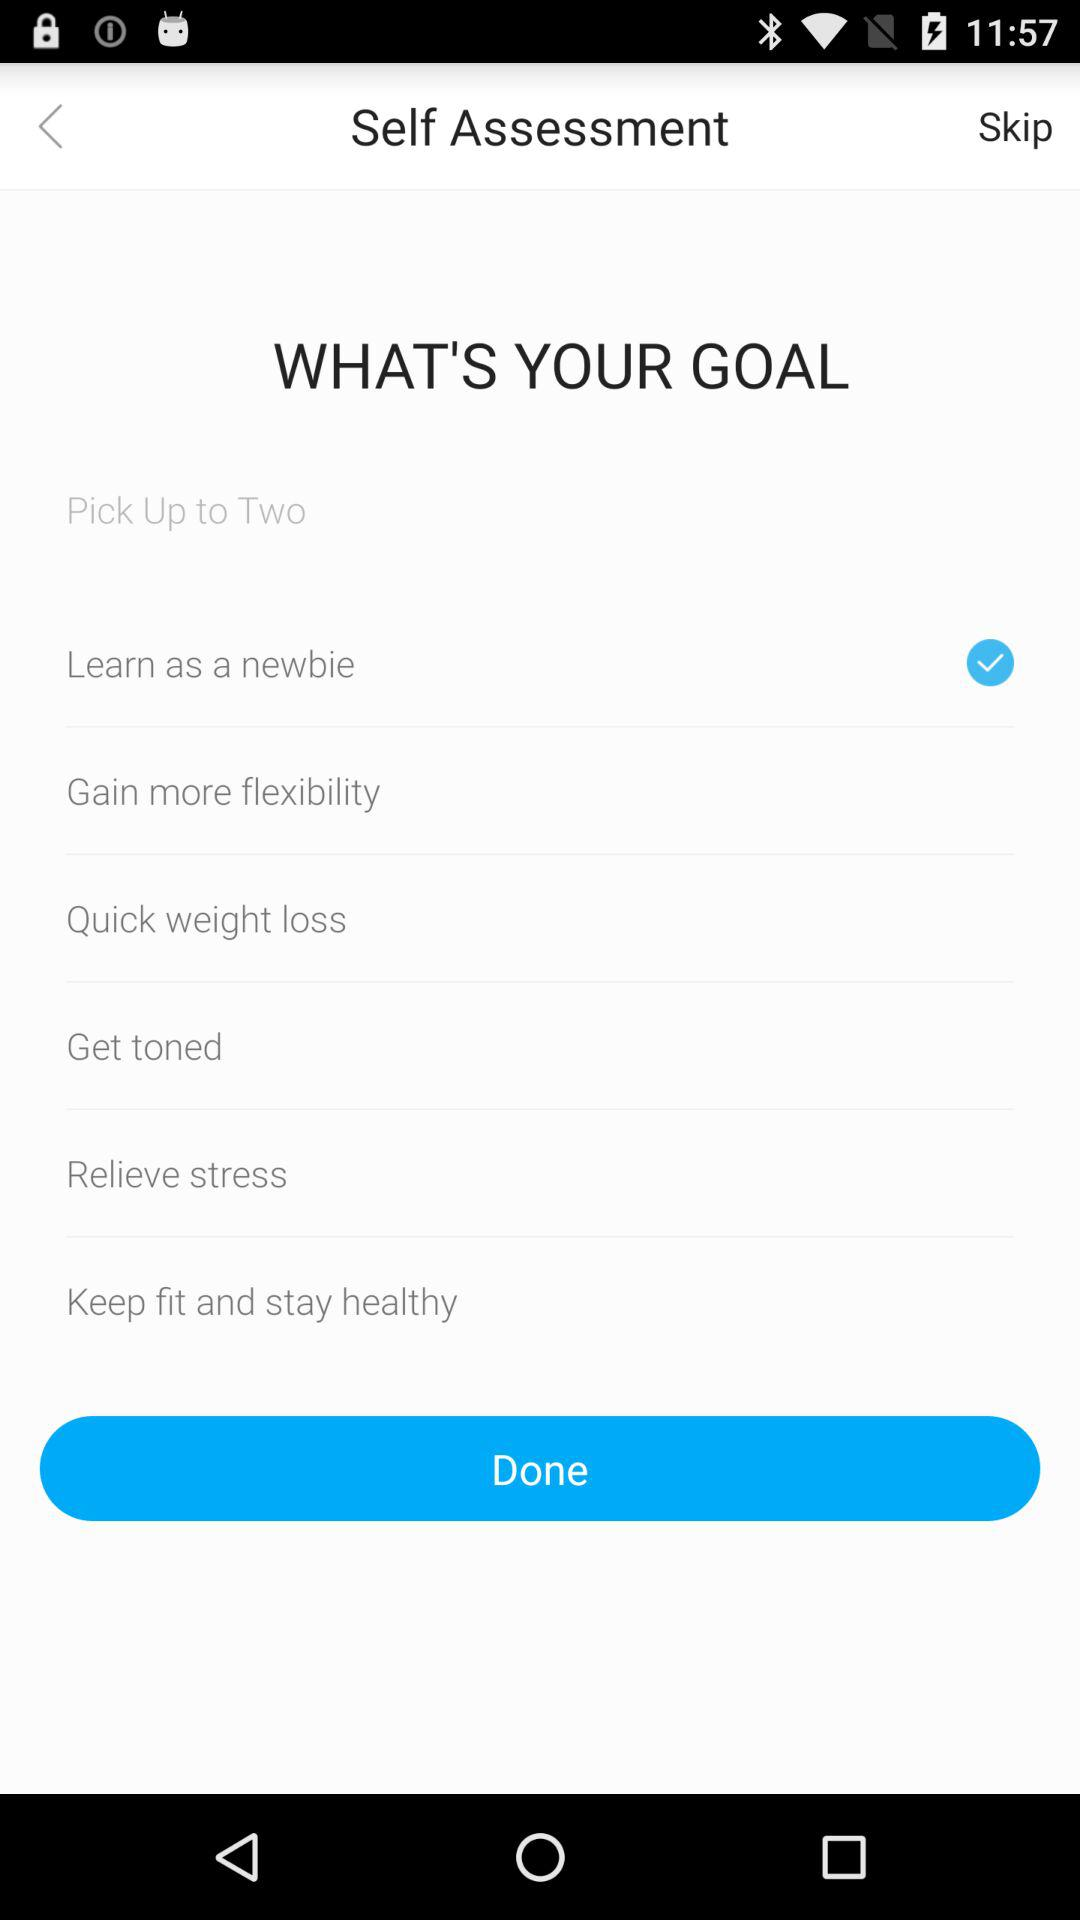Which option has been selected? The selected option is "Learn as a newbie". 